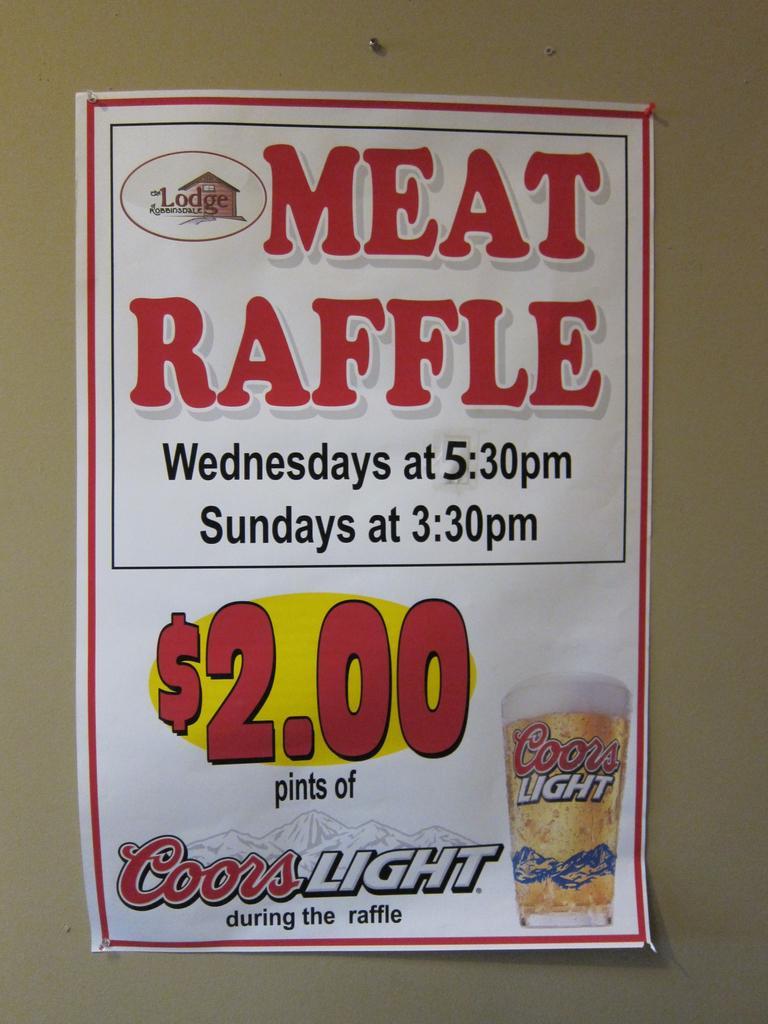How would you summarize this image in a sentence or two? In this image, we can see a poster with some text, a logo and a glass with drink is placed on the wall. 